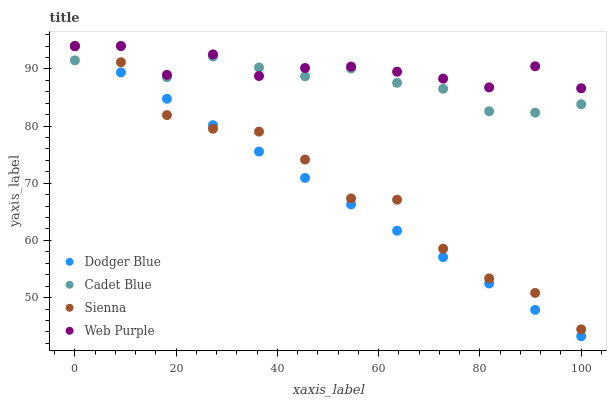Does Dodger Blue have the minimum area under the curve?
Answer yes or no. Yes. Does Web Purple have the maximum area under the curve?
Answer yes or no. Yes. Does Cadet Blue have the minimum area under the curve?
Answer yes or no. No. Does Cadet Blue have the maximum area under the curve?
Answer yes or no. No. Is Dodger Blue the smoothest?
Answer yes or no. Yes. Is Sienna the roughest?
Answer yes or no. Yes. Is Web Purple the smoothest?
Answer yes or no. No. Is Web Purple the roughest?
Answer yes or no. No. Does Dodger Blue have the lowest value?
Answer yes or no. Yes. Does Cadet Blue have the lowest value?
Answer yes or no. No. Does Dodger Blue have the highest value?
Answer yes or no. Yes. Is Sienna less than Web Purple?
Answer yes or no. Yes. Is Web Purple greater than Sienna?
Answer yes or no. Yes. Does Cadet Blue intersect Web Purple?
Answer yes or no. Yes. Is Cadet Blue less than Web Purple?
Answer yes or no. No. Is Cadet Blue greater than Web Purple?
Answer yes or no. No. Does Sienna intersect Web Purple?
Answer yes or no. No. 